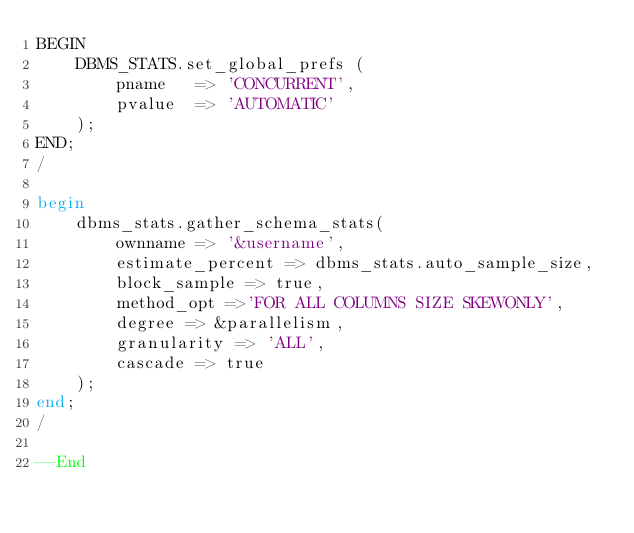<code> <loc_0><loc_0><loc_500><loc_500><_SQL_>BEGIN
    DBMS_STATS.set_global_prefs (
        pname   => 'CONCURRENT',
        pvalue  => 'AUTOMATIC'
    );
END;
/

begin
    dbms_stats.gather_schema_stats(
        ownname => '&username',
        estimate_percent => dbms_stats.auto_sample_size,
        block_sample => true,
        method_opt =>'FOR ALL COLUMNS SIZE SKEWONLY',
        degree => &parallelism,
        granularity => 'ALL',
        cascade => true
    );
end;
/

--End
</code> 